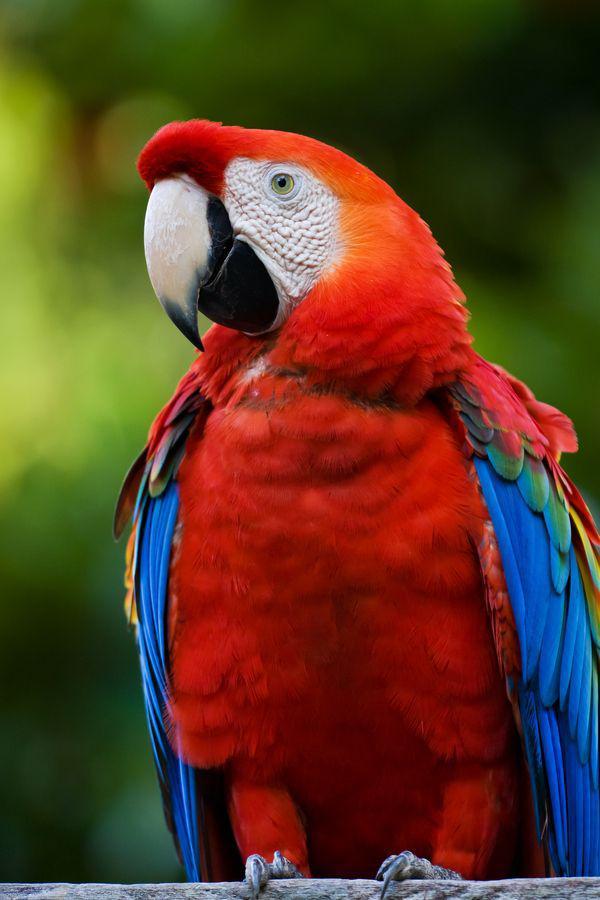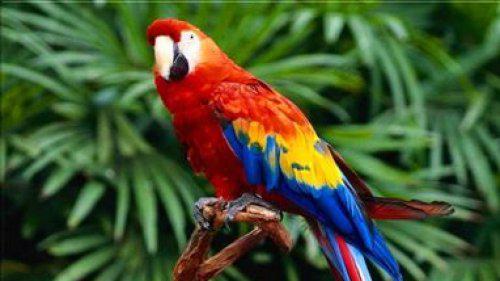The first image is the image on the left, the second image is the image on the right. Examine the images to the left and right. Is the description "The right image contains a single bird." accurate? Answer yes or no. Yes. 